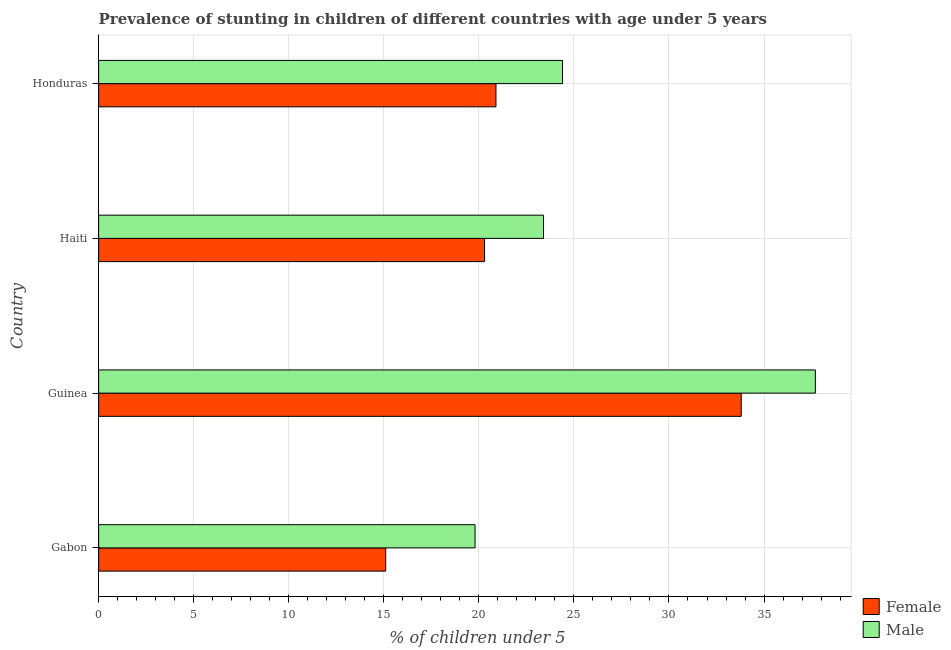Are the number of bars per tick equal to the number of legend labels?
Keep it short and to the point. Yes. How many bars are there on the 1st tick from the bottom?
Your answer should be very brief. 2. What is the label of the 1st group of bars from the top?
Offer a terse response. Honduras. What is the percentage of stunted male children in Gabon?
Your answer should be very brief. 19.8. Across all countries, what is the maximum percentage of stunted male children?
Provide a short and direct response. 37.7. Across all countries, what is the minimum percentage of stunted female children?
Make the answer very short. 15.1. In which country was the percentage of stunted male children maximum?
Ensure brevity in your answer.  Guinea. In which country was the percentage of stunted female children minimum?
Provide a short and direct response. Gabon. What is the total percentage of stunted male children in the graph?
Your response must be concise. 105.3. What is the difference between the percentage of stunted female children in Honduras and the percentage of stunted male children in Haiti?
Your response must be concise. -2.5. What is the average percentage of stunted male children per country?
Give a very brief answer. 26.32. What is the difference between the percentage of stunted female children and percentage of stunted male children in Honduras?
Your answer should be very brief. -3.5. In how many countries, is the percentage of stunted male children greater than 8 %?
Make the answer very short. 4. What is the ratio of the percentage of stunted female children in Guinea to that in Haiti?
Provide a short and direct response. 1.67. Is the difference between the percentage of stunted female children in Guinea and Honduras greater than the difference between the percentage of stunted male children in Guinea and Honduras?
Offer a terse response. No. What is the difference between the highest and the second highest percentage of stunted female children?
Keep it short and to the point. 12.9. What is the difference between the highest and the lowest percentage of stunted female children?
Your answer should be compact. 18.7. Is the sum of the percentage of stunted female children in Gabon and Guinea greater than the maximum percentage of stunted male children across all countries?
Provide a short and direct response. Yes. What does the 1st bar from the bottom in Guinea represents?
Your answer should be compact. Female. How many bars are there?
Your answer should be compact. 8. Are all the bars in the graph horizontal?
Keep it short and to the point. Yes. Does the graph contain grids?
Offer a very short reply. Yes. Where does the legend appear in the graph?
Offer a very short reply. Bottom right. How are the legend labels stacked?
Keep it short and to the point. Vertical. What is the title of the graph?
Your response must be concise. Prevalence of stunting in children of different countries with age under 5 years. What is the label or title of the X-axis?
Your answer should be very brief.  % of children under 5. What is the  % of children under 5 in Female in Gabon?
Your response must be concise. 15.1. What is the  % of children under 5 of Male in Gabon?
Your answer should be compact. 19.8. What is the  % of children under 5 in Female in Guinea?
Give a very brief answer. 33.8. What is the  % of children under 5 in Male in Guinea?
Provide a short and direct response. 37.7. What is the  % of children under 5 in Female in Haiti?
Your answer should be compact. 20.3. What is the  % of children under 5 of Male in Haiti?
Offer a very short reply. 23.4. What is the  % of children under 5 in Female in Honduras?
Provide a succinct answer. 20.9. What is the  % of children under 5 in Male in Honduras?
Offer a terse response. 24.4. Across all countries, what is the maximum  % of children under 5 in Female?
Ensure brevity in your answer.  33.8. Across all countries, what is the maximum  % of children under 5 of Male?
Keep it short and to the point. 37.7. Across all countries, what is the minimum  % of children under 5 of Female?
Offer a very short reply. 15.1. Across all countries, what is the minimum  % of children under 5 in Male?
Your answer should be compact. 19.8. What is the total  % of children under 5 of Female in the graph?
Ensure brevity in your answer.  90.1. What is the total  % of children under 5 of Male in the graph?
Ensure brevity in your answer.  105.3. What is the difference between the  % of children under 5 in Female in Gabon and that in Guinea?
Keep it short and to the point. -18.7. What is the difference between the  % of children under 5 in Male in Gabon and that in Guinea?
Offer a terse response. -17.9. What is the difference between the  % of children under 5 in Male in Gabon and that in Haiti?
Your answer should be very brief. -3.6. What is the difference between the  % of children under 5 of Female in Gabon and that in Honduras?
Provide a succinct answer. -5.8. What is the difference between the  % of children under 5 in Female in Guinea and that in Haiti?
Make the answer very short. 13.5. What is the difference between the  % of children under 5 in Female in Guinea and that in Honduras?
Ensure brevity in your answer.  12.9. What is the difference between the  % of children under 5 in Female in Haiti and that in Honduras?
Provide a short and direct response. -0.6. What is the difference between the  % of children under 5 of Male in Haiti and that in Honduras?
Give a very brief answer. -1. What is the difference between the  % of children under 5 of Female in Gabon and the  % of children under 5 of Male in Guinea?
Make the answer very short. -22.6. What is the difference between the  % of children under 5 of Female in Gabon and the  % of children under 5 of Male in Honduras?
Your answer should be very brief. -9.3. What is the difference between the  % of children under 5 in Female in Guinea and the  % of children under 5 in Male in Honduras?
Provide a succinct answer. 9.4. What is the average  % of children under 5 of Female per country?
Your answer should be very brief. 22.52. What is the average  % of children under 5 in Male per country?
Offer a terse response. 26.32. What is the difference between the  % of children under 5 of Female and  % of children under 5 of Male in Gabon?
Give a very brief answer. -4.7. What is the difference between the  % of children under 5 in Female and  % of children under 5 in Male in Guinea?
Your answer should be compact. -3.9. What is the difference between the  % of children under 5 of Female and  % of children under 5 of Male in Haiti?
Keep it short and to the point. -3.1. What is the ratio of the  % of children under 5 in Female in Gabon to that in Guinea?
Your answer should be very brief. 0.45. What is the ratio of the  % of children under 5 in Male in Gabon to that in Guinea?
Ensure brevity in your answer.  0.53. What is the ratio of the  % of children under 5 in Female in Gabon to that in Haiti?
Offer a very short reply. 0.74. What is the ratio of the  % of children under 5 in Male in Gabon to that in Haiti?
Your answer should be compact. 0.85. What is the ratio of the  % of children under 5 of Female in Gabon to that in Honduras?
Offer a terse response. 0.72. What is the ratio of the  % of children under 5 in Male in Gabon to that in Honduras?
Keep it short and to the point. 0.81. What is the ratio of the  % of children under 5 in Female in Guinea to that in Haiti?
Keep it short and to the point. 1.67. What is the ratio of the  % of children under 5 in Male in Guinea to that in Haiti?
Your answer should be very brief. 1.61. What is the ratio of the  % of children under 5 of Female in Guinea to that in Honduras?
Keep it short and to the point. 1.62. What is the ratio of the  % of children under 5 in Male in Guinea to that in Honduras?
Make the answer very short. 1.55. What is the ratio of the  % of children under 5 in Female in Haiti to that in Honduras?
Offer a terse response. 0.97. What is the ratio of the  % of children under 5 of Male in Haiti to that in Honduras?
Keep it short and to the point. 0.96. What is the difference between the highest and the second highest  % of children under 5 of Female?
Provide a succinct answer. 12.9. What is the difference between the highest and the second highest  % of children under 5 in Male?
Give a very brief answer. 13.3. What is the difference between the highest and the lowest  % of children under 5 in Female?
Provide a succinct answer. 18.7. 